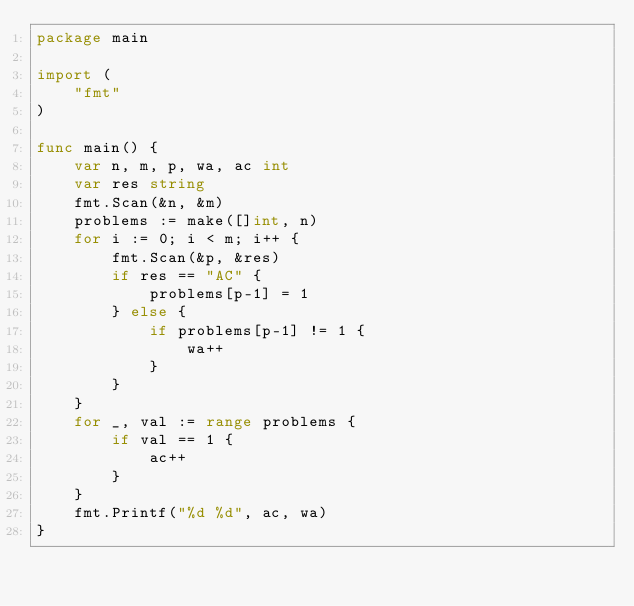<code> <loc_0><loc_0><loc_500><loc_500><_Go_>package main

import (
	"fmt"
)

func main() {
	var n, m, p, wa, ac int
	var res string
	fmt.Scan(&n, &m)
	problems := make([]int, n)
	for i := 0; i < m; i++ {
		fmt.Scan(&p, &res)
		if res == "AC" {
			problems[p-1] = 1
		} else {
			if problems[p-1] != 1 {
				wa++
			}
		}
	}
	for _, val := range problems {
		if val == 1 {
			ac++
		}
	}
	fmt.Printf("%d %d", ac, wa)
}
</code> 